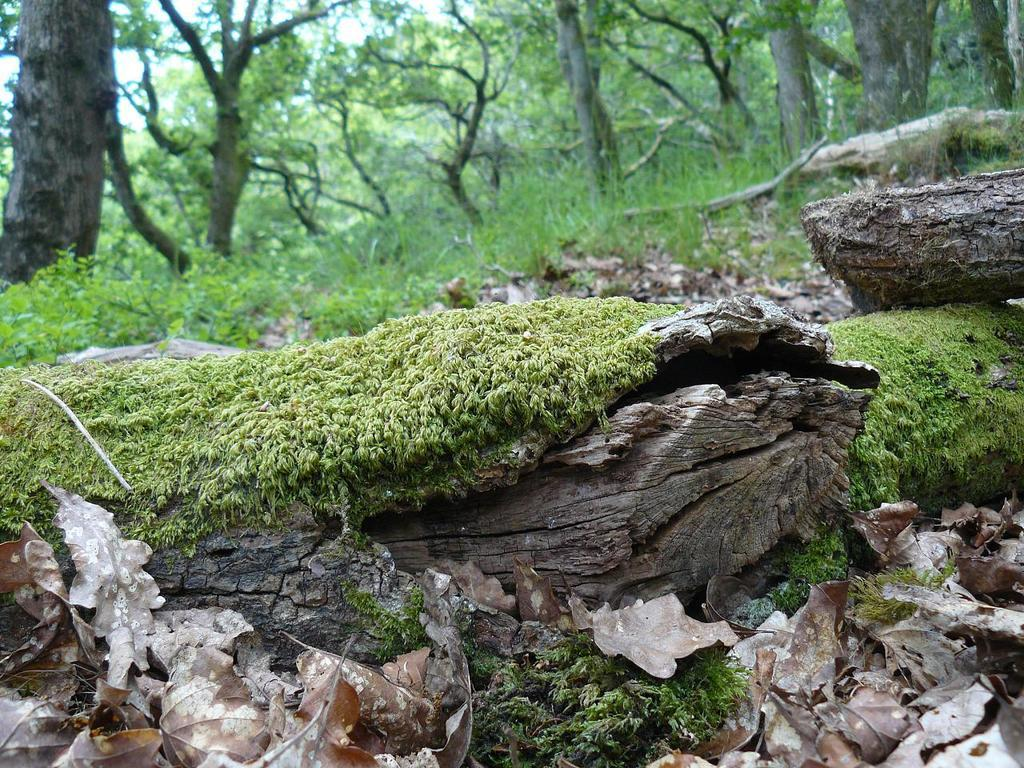What type of vegetation is present in the image? There is grass and plants in the image. What can be seen in the background of the image? There are trees and the sky visible in the background of the image. What is the stranger's temper like in the image? There is no stranger present in the image, so it is not possible to determine their temper. 